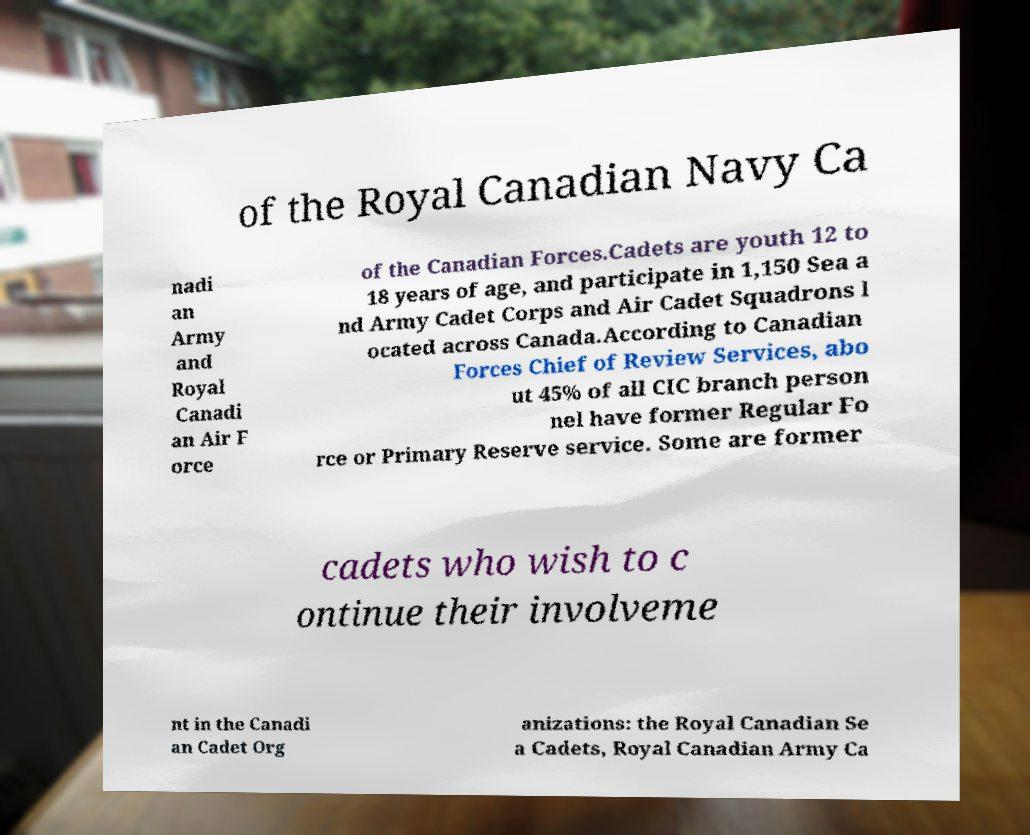Please identify and transcribe the text found in this image. of the Royal Canadian Navy Ca nadi an Army and Royal Canadi an Air F orce of the Canadian Forces.Cadets are youth 12 to 18 years of age, and participate in 1,150 Sea a nd Army Cadet Corps and Air Cadet Squadrons l ocated across Canada.According to Canadian Forces Chief of Review Services, abo ut 45% of all CIC branch person nel have former Regular Fo rce or Primary Reserve service. Some are former cadets who wish to c ontinue their involveme nt in the Canadi an Cadet Org anizations: the Royal Canadian Se a Cadets, Royal Canadian Army Ca 